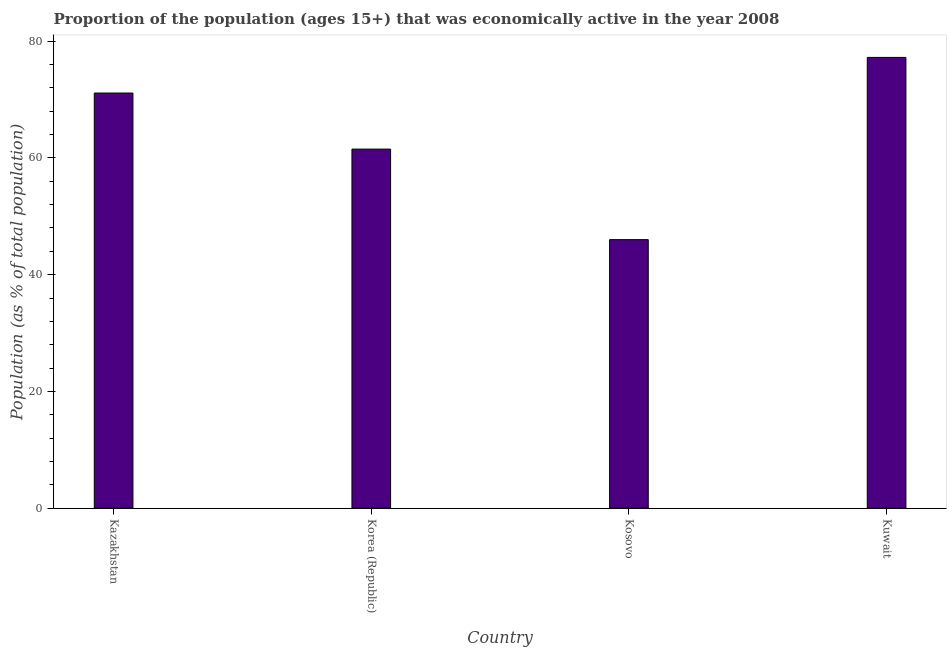What is the title of the graph?
Offer a terse response. Proportion of the population (ages 15+) that was economically active in the year 2008. What is the label or title of the Y-axis?
Your response must be concise. Population (as % of total population). Across all countries, what is the maximum percentage of economically active population?
Provide a succinct answer. 77.2. Across all countries, what is the minimum percentage of economically active population?
Your answer should be very brief. 46. In which country was the percentage of economically active population maximum?
Your answer should be compact. Kuwait. In which country was the percentage of economically active population minimum?
Keep it short and to the point. Kosovo. What is the sum of the percentage of economically active population?
Make the answer very short. 255.8. What is the difference between the percentage of economically active population in Kosovo and Kuwait?
Your response must be concise. -31.2. What is the average percentage of economically active population per country?
Provide a succinct answer. 63.95. What is the median percentage of economically active population?
Provide a succinct answer. 66.3. What is the ratio of the percentage of economically active population in Kazakhstan to that in Kuwait?
Provide a short and direct response. 0.92. Is the difference between the percentage of economically active population in Kazakhstan and Kuwait greater than the difference between any two countries?
Offer a terse response. No. Is the sum of the percentage of economically active population in Kazakhstan and Kosovo greater than the maximum percentage of economically active population across all countries?
Your response must be concise. Yes. What is the difference between the highest and the lowest percentage of economically active population?
Ensure brevity in your answer.  31.2. How many countries are there in the graph?
Give a very brief answer. 4. What is the Population (as % of total population) in Kazakhstan?
Make the answer very short. 71.1. What is the Population (as % of total population) of Korea (Republic)?
Your response must be concise. 61.5. What is the Population (as % of total population) in Kuwait?
Your answer should be very brief. 77.2. What is the difference between the Population (as % of total population) in Kazakhstan and Kosovo?
Provide a short and direct response. 25.1. What is the difference between the Population (as % of total population) in Korea (Republic) and Kuwait?
Make the answer very short. -15.7. What is the difference between the Population (as % of total population) in Kosovo and Kuwait?
Give a very brief answer. -31.2. What is the ratio of the Population (as % of total population) in Kazakhstan to that in Korea (Republic)?
Your answer should be very brief. 1.16. What is the ratio of the Population (as % of total population) in Kazakhstan to that in Kosovo?
Ensure brevity in your answer.  1.55. What is the ratio of the Population (as % of total population) in Kazakhstan to that in Kuwait?
Your response must be concise. 0.92. What is the ratio of the Population (as % of total population) in Korea (Republic) to that in Kosovo?
Keep it short and to the point. 1.34. What is the ratio of the Population (as % of total population) in Korea (Republic) to that in Kuwait?
Offer a terse response. 0.8. What is the ratio of the Population (as % of total population) in Kosovo to that in Kuwait?
Keep it short and to the point. 0.6. 